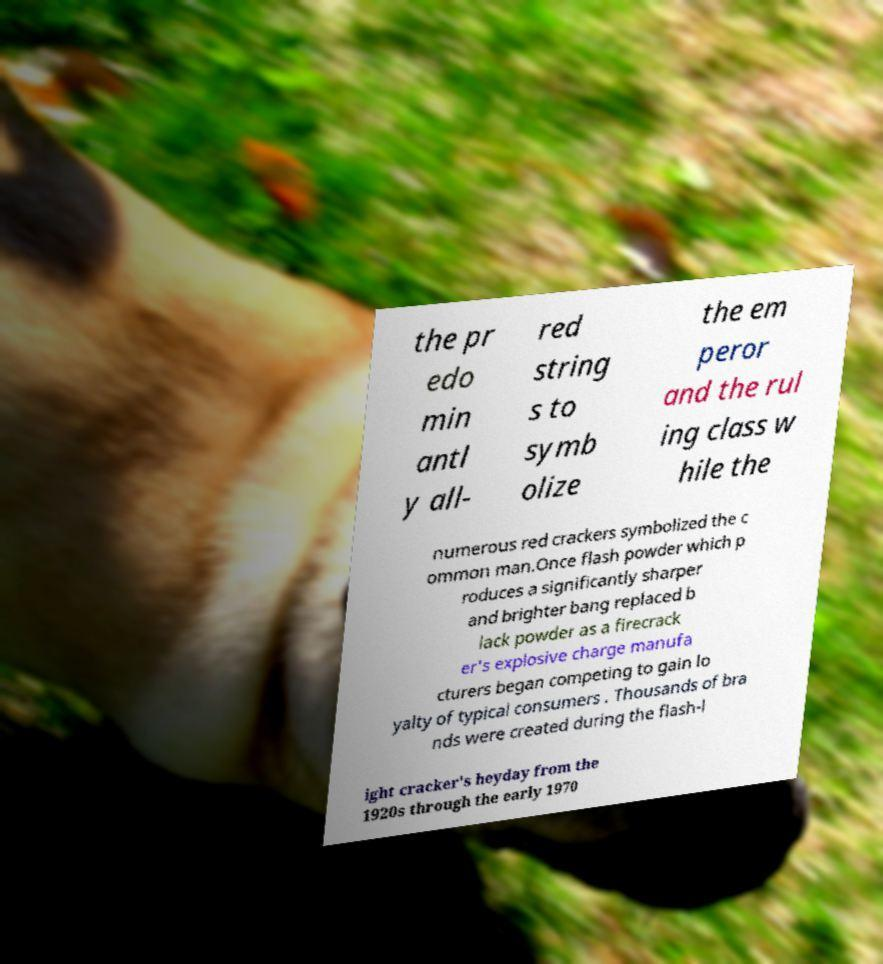There's text embedded in this image that I need extracted. Can you transcribe it verbatim? the pr edo min antl y all- red string s to symb olize the em peror and the rul ing class w hile the numerous red crackers symbolized the c ommon man.Once flash powder which p roduces a significantly sharper and brighter bang replaced b lack powder as a firecrack er's explosive charge manufa cturers began competing to gain lo yalty of typical consumers . Thousands of bra nds were created during the flash-l ight cracker's heyday from the 1920s through the early 1970 